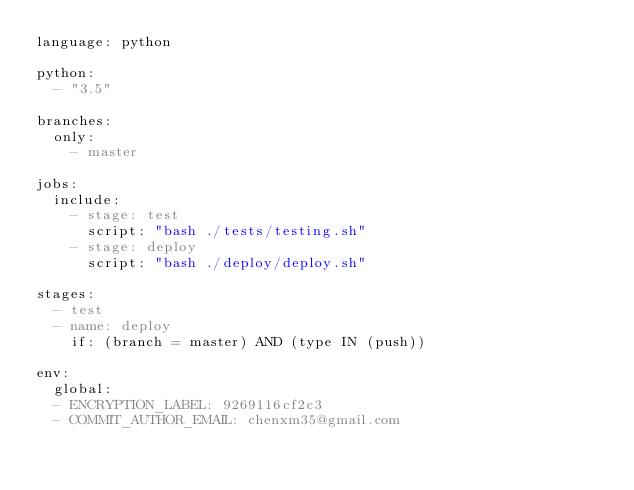<code> <loc_0><loc_0><loc_500><loc_500><_YAML_>language: python

python:
  - "3.5"

branches:
  only:
    - master

jobs:
  include:
    - stage: test
      script: "bash ./tests/testing.sh"
    - stage: deploy
      script: "bash ./deploy/deploy.sh"

stages:
  - test
  - name: deploy
    if: (branch = master) AND (type IN (push))
    
env:
  global:
  - ENCRYPTION_LABEL: 9269116cf2c3
  - COMMIT_AUTHOR_EMAIL: chenxm35@gmail.com
</code> 